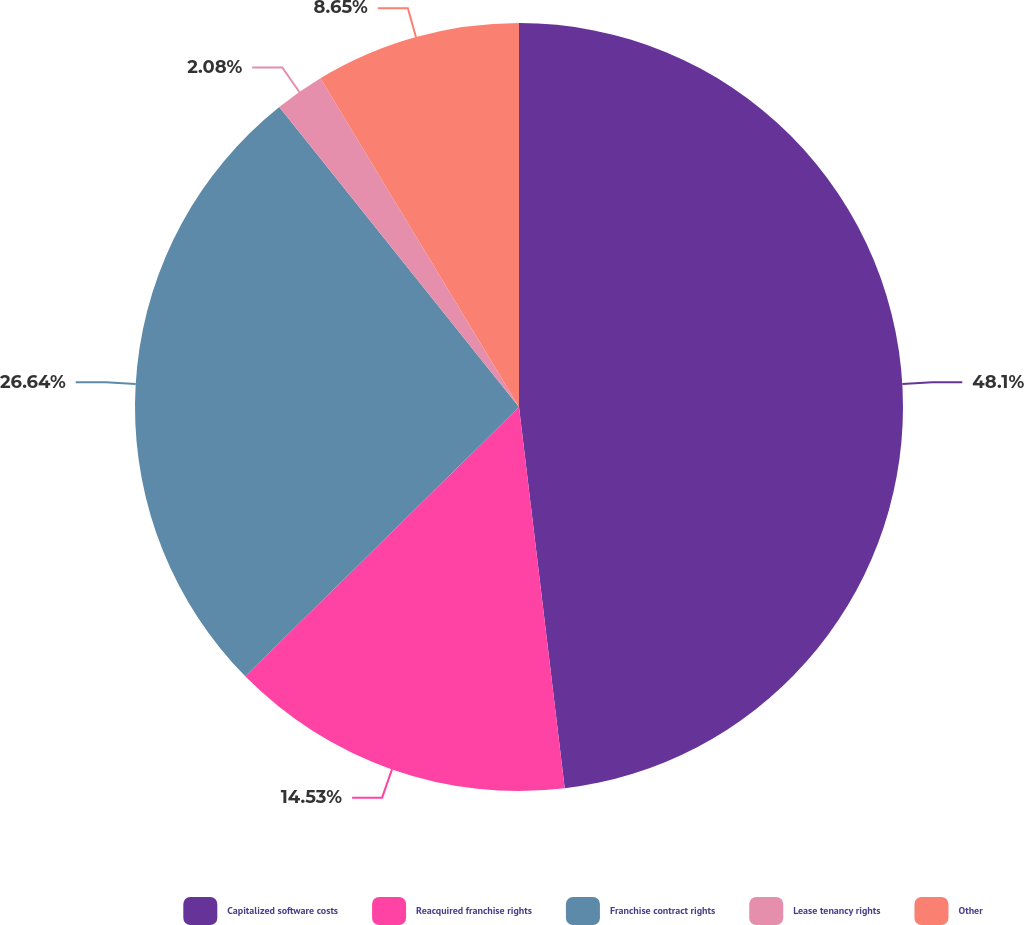Convert chart. <chart><loc_0><loc_0><loc_500><loc_500><pie_chart><fcel>Capitalized software costs<fcel>Reacquired franchise rights<fcel>Franchise contract rights<fcel>Lease tenancy rights<fcel>Other<nl><fcel>48.1%<fcel>14.53%<fcel>26.64%<fcel>2.08%<fcel>8.65%<nl></chart> 